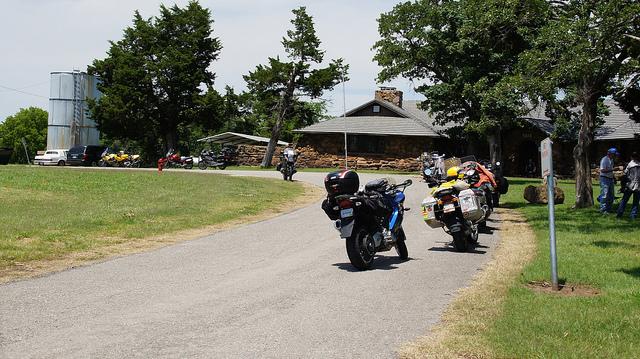Where are the bikes parked?
Answer briefly. Road. How many bikes are there?
Be succinct. 4. Is it important to have motorcycle training before driving a motorcycle on the road?
Give a very brief answer. Yes. 